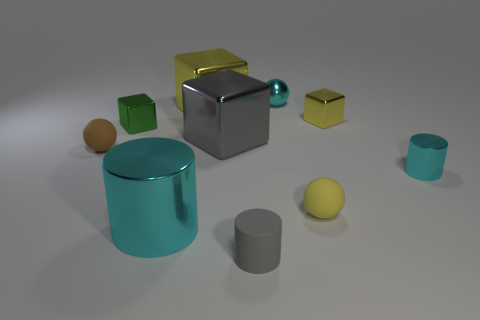Subtract 1 balls. How many balls are left? 2 Add 5 small green things. How many small green things are left? 6 Add 3 cyan metallic cylinders. How many cyan metallic cylinders exist? 5 Subtract all brown spheres. How many spheres are left? 2 Subtract all green blocks. How many blocks are left? 3 Subtract 1 yellow balls. How many objects are left? 9 Subtract all blocks. How many objects are left? 6 Subtract all green cubes. Subtract all brown spheres. How many cubes are left? 3 Subtract all cyan spheres. How many cyan cylinders are left? 2 Subtract all green rubber cylinders. Subtract all brown balls. How many objects are left? 9 